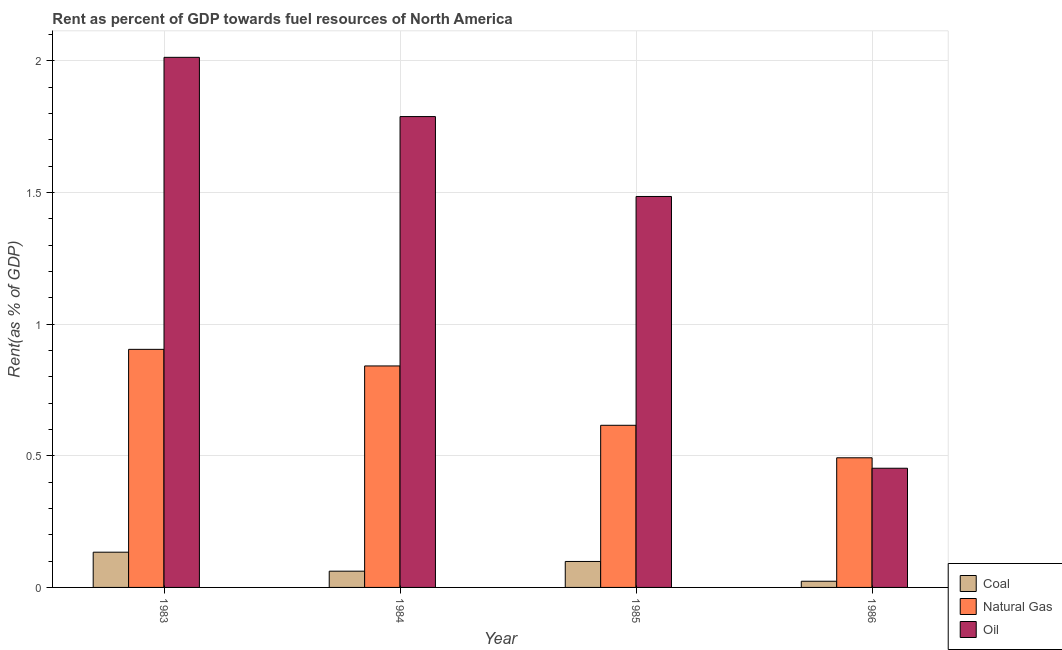How many groups of bars are there?
Offer a terse response. 4. Are the number of bars per tick equal to the number of legend labels?
Give a very brief answer. Yes. Are the number of bars on each tick of the X-axis equal?
Give a very brief answer. Yes. How many bars are there on the 1st tick from the right?
Provide a short and direct response. 3. What is the label of the 3rd group of bars from the left?
Give a very brief answer. 1985. What is the rent towards coal in 1984?
Give a very brief answer. 0.06. Across all years, what is the maximum rent towards coal?
Provide a succinct answer. 0.13. Across all years, what is the minimum rent towards coal?
Provide a succinct answer. 0.02. In which year was the rent towards natural gas maximum?
Provide a short and direct response. 1983. In which year was the rent towards coal minimum?
Your response must be concise. 1986. What is the total rent towards oil in the graph?
Offer a terse response. 5.74. What is the difference between the rent towards coal in 1983 and that in 1985?
Provide a succinct answer. 0.04. What is the difference between the rent towards coal in 1983 and the rent towards natural gas in 1986?
Ensure brevity in your answer.  0.11. What is the average rent towards oil per year?
Keep it short and to the point. 1.43. In the year 1985, what is the difference between the rent towards oil and rent towards natural gas?
Ensure brevity in your answer.  0. In how many years, is the rent towards oil greater than 1.6 %?
Offer a terse response. 2. What is the ratio of the rent towards coal in 1983 to that in 1984?
Provide a short and direct response. 2.17. Is the rent towards oil in 1983 less than that in 1986?
Your answer should be very brief. No. Is the difference between the rent towards natural gas in 1984 and 1986 greater than the difference between the rent towards coal in 1984 and 1986?
Make the answer very short. No. What is the difference between the highest and the second highest rent towards oil?
Provide a succinct answer. 0.23. What is the difference between the highest and the lowest rent towards natural gas?
Provide a succinct answer. 0.41. In how many years, is the rent towards oil greater than the average rent towards oil taken over all years?
Your answer should be very brief. 3. What does the 2nd bar from the left in 1983 represents?
Offer a very short reply. Natural Gas. What does the 2nd bar from the right in 1985 represents?
Keep it short and to the point. Natural Gas. How many bars are there?
Offer a very short reply. 12. Does the graph contain any zero values?
Make the answer very short. No. How many legend labels are there?
Make the answer very short. 3. What is the title of the graph?
Keep it short and to the point. Rent as percent of GDP towards fuel resources of North America. What is the label or title of the Y-axis?
Ensure brevity in your answer.  Rent(as % of GDP). What is the Rent(as % of GDP) of Coal in 1983?
Provide a short and direct response. 0.13. What is the Rent(as % of GDP) in Natural Gas in 1983?
Make the answer very short. 0.9. What is the Rent(as % of GDP) of Oil in 1983?
Make the answer very short. 2.01. What is the Rent(as % of GDP) in Coal in 1984?
Offer a very short reply. 0.06. What is the Rent(as % of GDP) in Natural Gas in 1984?
Provide a succinct answer. 0.84. What is the Rent(as % of GDP) of Oil in 1984?
Provide a short and direct response. 1.79. What is the Rent(as % of GDP) of Coal in 1985?
Your answer should be very brief. 0.1. What is the Rent(as % of GDP) in Natural Gas in 1985?
Offer a terse response. 0.62. What is the Rent(as % of GDP) of Oil in 1985?
Ensure brevity in your answer.  1.49. What is the Rent(as % of GDP) of Coal in 1986?
Provide a succinct answer. 0.02. What is the Rent(as % of GDP) of Natural Gas in 1986?
Offer a terse response. 0.49. What is the Rent(as % of GDP) in Oil in 1986?
Give a very brief answer. 0.45. Across all years, what is the maximum Rent(as % of GDP) of Coal?
Keep it short and to the point. 0.13. Across all years, what is the maximum Rent(as % of GDP) of Natural Gas?
Provide a succinct answer. 0.9. Across all years, what is the maximum Rent(as % of GDP) of Oil?
Provide a short and direct response. 2.01. Across all years, what is the minimum Rent(as % of GDP) in Coal?
Offer a terse response. 0.02. Across all years, what is the minimum Rent(as % of GDP) in Natural Gas?
Provide a succinct answer. 0.49. Across all years, what is the minimum Rent(as % of GDP) in Oil?
Provide a short and direct response. 0.45. What is the total Rent(as % of GDP) in Coal in the graph?
Your answer should be very brief. 0.32. What is the total Rent(as % of GDP) of Natural Gas in the graph?
Your answer should be very brief. 2.85. What is the total Rent(as % of GDP) of Oil in the graph?
Make the answer very short. 5.74. What is the difference between the Rent(as % of GDP) of Coal in 1983 and that in 1984?
Your answer should be compact. 0.07. What is the difference between the Rent(as % of GDP) in Natural Gas in 1983 and that in 1984?
Your response must be concise. 0.06. What is the difference between the Rent(as % of GDP) of Oil in 1983 and that in 1984?
Your answer should be very brief. 0.23. What is the difference between the Rent(as % of GDP) of Coal in 1983 and that in 1985?
Offer a terse response. 0.04. What is the difference between the Rent(as % of GDP) in Natural Gas in 1983 and that in 1985?
Make the answer very short. 0.29. What is the difference between the Rent(as % of GDP) in Oil in 1983 and that in 1985?
Make the answer very short. 0.53. What is the difference between the Rent(as % of GDP) of Coal in 1983 and that in 1986?
Provide a succinct answer. 0.11. What is the difference between the Rent(as % of GDP) in Natural Gas in 1983 and that in 1986?
Give a very brief answer. 0.41. What is the difference between the Rent(as % of GDP) of Oil in 1983 and that in 1986?
Give a very brief answer. 1.56. What is the difference between the Rent(as % of GDP) of Coal in 1984 and that in 1985?
Provide a succinct answer. -0.04. What is the difference between the Rent(as % of GDP) in Natural Gas in 1984 and that in 1985?
Offer a very short reply. 0.23. What is the difference between the Rent(as % of GDP) of Oil in 1984 and that in 1985?
Give a very brief answer. 0.3. What is the difference between the Rent(as % of GDP) of Coal in 1984 and that in 1986?
Keep it short and to the point. 0.04. What is the difference between the Rent(as % of GDP) in Natural Gas in 1984 and that in 1986?
Give a very brief answer. 0.35. What is the difference between the Rent(as % of GDP) of Oil in 1984 and that in 1986?
Provide a short and direct response. 1.34. What is the difference between the Rent(as % of GDP) of Coal in 1985 and that in 1986?
Ensure brevity in your answer.  0.08. What is the difference between the Rent(as % of GDP) in Natural Gas in 1985 and that in 1986?
Provide a short and direct response. 0.12. What is the difference between the Rent(as % of GDP) of Oil in 1985 and that in 1986?
Ensure brevity in your answer.  1.03. What is the difference between the Rent(as % of GDP) in Coal in 1983 and the Rent(as % of GDP) in Natural Gas in 1984?
Give a very brief answer. -0.71. What is the difference between the Rent(as % of GDP) in Coal in 1983 and the Rent(as % of GDP) in Oil in 1984?
Give a very brief answer. -1.65. What is the difference between the Rent(as % of GDP) in Natural Gas in 1983 and the Rent(as % of GDP) in Oil in 1984?
Your answer should be very brief. -0.88. What is the difference between the Rent(as % of GDP) in Coal in 1983 and the Rent(as % of GDP) in Natural Gas in 1985?
Your answer should be very brief. -0.48. What is the difference between the Rent(as % of GDP) of Coal in 1983 and the Rent(as % of GDP) of Oil in 1985?
Provide a short and direct response. -1.35. What is the difference between the Rent(as % of GDP) in Natural Gas in 1983 and the Rent(as % of GDP) in Oil in 1985?
Keep it short and to the point. -0.58. What is the difference between the Rent(as % of GDP) of Coal in 1983 and the Rent(as % of GDP) of Natural Gas in 1986?
Ensure brevity in your answer.  -0.36. What is the difference between the Rent(as % of GDP) in Coal in 1983 and the Rent(as % of GDP) in Oil in 1986?
Your answer should be compact. -0.32. What is the difference between the Rent(as % of GDP) in Natural Gas in 1983 and the Rent(as % of GDP) in Oil in 1986?
Make the answer very short. 0.45. What is the difference between the Rent(as % of GDP) of Coal in 1984 and the Rent(as % of GDP) of Natural Gas in 1985?
Your answer should be compact. -0.55. What is the difference between the Rent(as % of GDP) in Coal in 1984 and the Rent(as % of GDP) in Oil in 1985?
Ensure brevity in your answer.  -1.42. What is the difference between the Rent(as % of GDP) in Natural Gas in 1984 and the Rent(as % of GDP) in Oil in 1985?
Your response must be concise. -0.64. What is the difference between the Rent(as % of GDP) of Coal in 1984 and the Rent(as % of GDP) of Natural Gas in 1986?
Ensure brevity in your answer.  -0.43. What is the difference between the Rent(as % of GDP) in Coal in 1984 and the Rent(as % of GDP) in Oil in 1986?
Offer a terse response. -0.39. What is the difference between the Rent(as % of GDP) of Natural Gas in 1984 and the Rent(as % of GDP) of Oil in 1986?
Keep it short and to the point. 0.39. What is the difference between the Rent(as % of GDP) of Coal in 1985 and the Rent(as % of GDP) of Natural Gas in 1986?
Ensure brevity in your answer.  -0.39. What is the difference between the Rent(as % of GDP) of Coal in 1985 and the Rent(as % of GDP) of Oil in 1986?
Provide a short and direct response. -0.35. What is the difference between the Rent(as % of GDP) in Natural Gas in 1985 and the Rent(as % of GDP) in Oil in 1986?
Provide a succinct answer. 0.16. What is the average Rent(as % of GDP) in Coal per year?
Your response must be concise. 0.08. What is the average Rent(as % of GDP) of Natural Gas per year?
Ensure brevity in your answer.  0.71. What is the average Rent(as % of GDP) of Oil per year?
Offer a very short reply. 1.44. In the year 1983, what is the difference between the Rent(as % of GDP) in Coal and Rent(as % of GDP) in Natural Gas?
Keep it short and to the point. -0.77. In the year 1983, what is the difference between the Rent(as % of GDP) in Coal and Rent(as % of GDP) in Oil?
Keep it short and to the point. -1.88. In the year 1983, what is the difference between the Rent(as % of GDP) of Natural Gas and Rent(as % of GDP) of Oil?
Provide a succinct answer. -1.11. In the year 1984, what is the difference between the Rent(as % of GDP) in Coal and Rent(as % of GDP) in Natural Gas?
Your answer should be compact. -0.78. In the year 1984, what is the difference between the Rent(as % of GDP) of Coal and Rent(as % of GDP) of Oil?
Make the answer very short. -1.73. In the year 1984, what is the difference between the Rent(as % of GDP) of Natural Gas and Rent(as % of GDP) of Oil?
Keep it short and to the point. -0.95. In the year 1985, what is the difference between the Rent(as % of GDP) of Coal and Rent(as % of GDP) of Natural Gas?
Provide a succinct answer. -0.52. In the year 1985, what is the difference between the Rent(as % of GDP) of Coal and Rent(as % of GDP) of Oil?
Your answer should be compact. -1.39. In the year 1985, what is the difference between the Rent(as % of GDP) in Natural Gas and Rent(as % of GDP) in Oil?
Give a very brief answer. -0.87. In the year 1986, what is the difference between the Rent(as % of GDP) of Coal and Rent(as % of GDP) of Natural Gas?
Provide a succinct answer. -0.47. In the year 1986, what is the difference between the Rent(as % of GDP) in Coal and Rent(as % of GDP) in Oil?
Your response must be concise. -0.43. In the year 1986, what is the difference between the Rent(as % of GDP) of Natural Gas and Rent(as % of GDP) of Oil?
Your response must be concise. 0.04. What is the ratio of the Rent(as % of GDP) in Coal in 1983 to that in 1984?
Offer a very short reply. 2.17. What is the ratio of the Rent(as % of GDP) in Natural Gas in 1983 to that in 1984?
Offer a very short reply. 1.07. What is the ratio of the Rent(as % of GDP) in Oil in 1983 to that in 1984?
Your response must be concise. 1.13. What is the ratio of the Rent(as % of GDP) of Coal in 1983 to that in 1985?
Your answer should be compact. 1.36. What is the ratio of the Rent(as % of GDP) of Natural Gas in 1983 to that in 1985?
Your response must be concise. 1.47. What is the ratio of the Rent(as % of GDP) of Oil in 1983 to that in 1985?
Your answer should be compact. 1.36. What is the ratio of the Rent(as % of GDP) of Coal in 1983 to that in 1986?
Make the answer very short. 5.69. What is the ratio of the Rent(as % of GDP) of Natural Gas in 1983 to that in 1986?
Keep it short and to the point. 1.84. What is the ratio of the Rent(as % of GDP) in Oil in 1983 to that in 1986?
Give a very brief answer. 4.45. What is the ratio of the Rent(as % of GDP) in Coal in 1984 to that in 1985?
Your answer should be compact. 0.63. What is the ratio of the Rent(as % of GDP) of Natural Gas in 1984 to that in 1985?
Your answer should be very brief. 1.37. What is the ratio of the Rent(as % of GDP) in Oil in 1984 to that in 1985?
Your answer should be very brief. 1.2. What is the ratio of the Rent(as % of GDP) in Coal in 1984 to that in 1986?
Keep it short and to the point. 2.63. What is the ratio of the Rent(as % of GDP) in Natural Gas in 1984 to that in 1986?
Ensure brevity in your answer.  1.71. What is the ratio of the Rent(as % of GDP) in Oil in 1984 to that in 1986?
Offer a very short reply. 3.95. What is the ratio of the Rent(as % of GDP) of Coal in 1985 to that in 1986?
Offer a very short reply. 4.2. What is the ratio of the Rent(as % of GDP) of Natural Gas in 1985 to that in 1986?
Provide a succinct answer. 1.25. What is the ratio of the Rent(as % of GDP) in Oil in 1985 to that in 1986?
Your response must be concise. 3.28. What is the difference between the highest and the second highest Rent(as % of GDP) in Coal?
Your answer should be very brief. 0.04. What is the difference between the highest and the second highest Rent(as % of GDP) of Natural Gas?
Make the answer very short. 0.06. What is the difference between the highest and the second highest Rent(as % of GDP) of Oil?
Provide a succinct answer. 0.23. What is the difference between the highest and the lowest Rent(as % of GDP) of Coal?
Offer a terse response. 0.11. What is the difference between the highest and the lowest Rent(as % of GDP) of Natural Gas?
Offer a very short reply. 0.41. What is the difference between the highest and the lowest Rent(as % of GDP) in Oil?
Give a very brief answer. 1.56. 